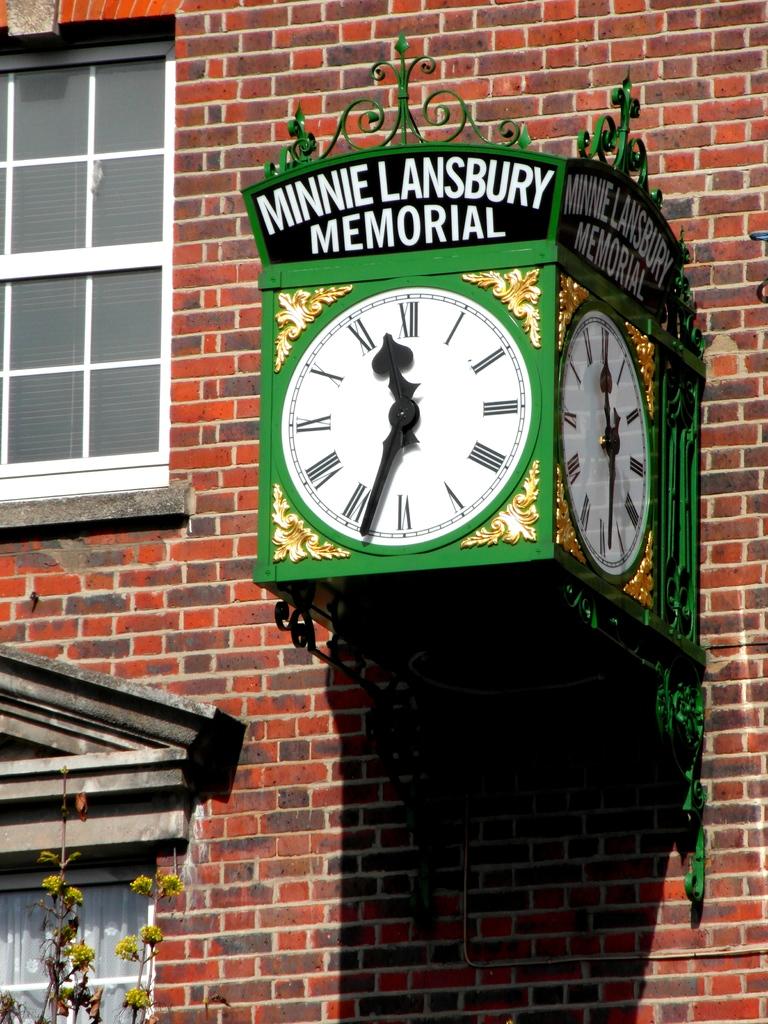Who is the memorial for?
Your answer should be compact. Minnie lansbury. What time is it?
Give a very brief answer. 11:34. 